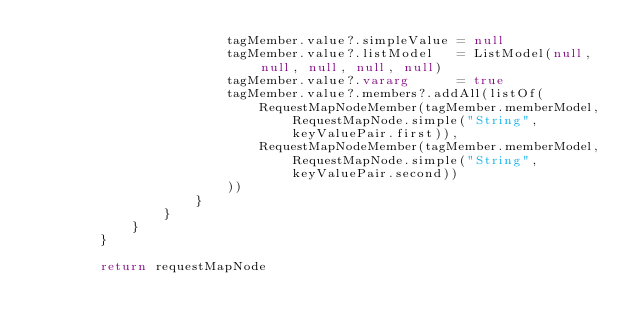Convert code to text. <code><loc_0><loc_0><loc_500><loc_500><_Kotlin_>                        tagMember.value?.simpleValue = null
                        tagMember.value?.listModel   = ListModel(null, null, null, null, null)
                        tagMember.value?.vararg      = true
                        tagMember.value?.members?.addAll(listOf(
                            RequestMapNodeMember(tagMember.memberModel, RequestMapNode.simple("String", keyValuePair.first)),
                            RequestMapNodeMember(tagMember.memberModel, RequestMapNode.simple("String", keyValuePair.second))
                        ))
                    }
                }
            }
        }

        return requestMapNode</code> 